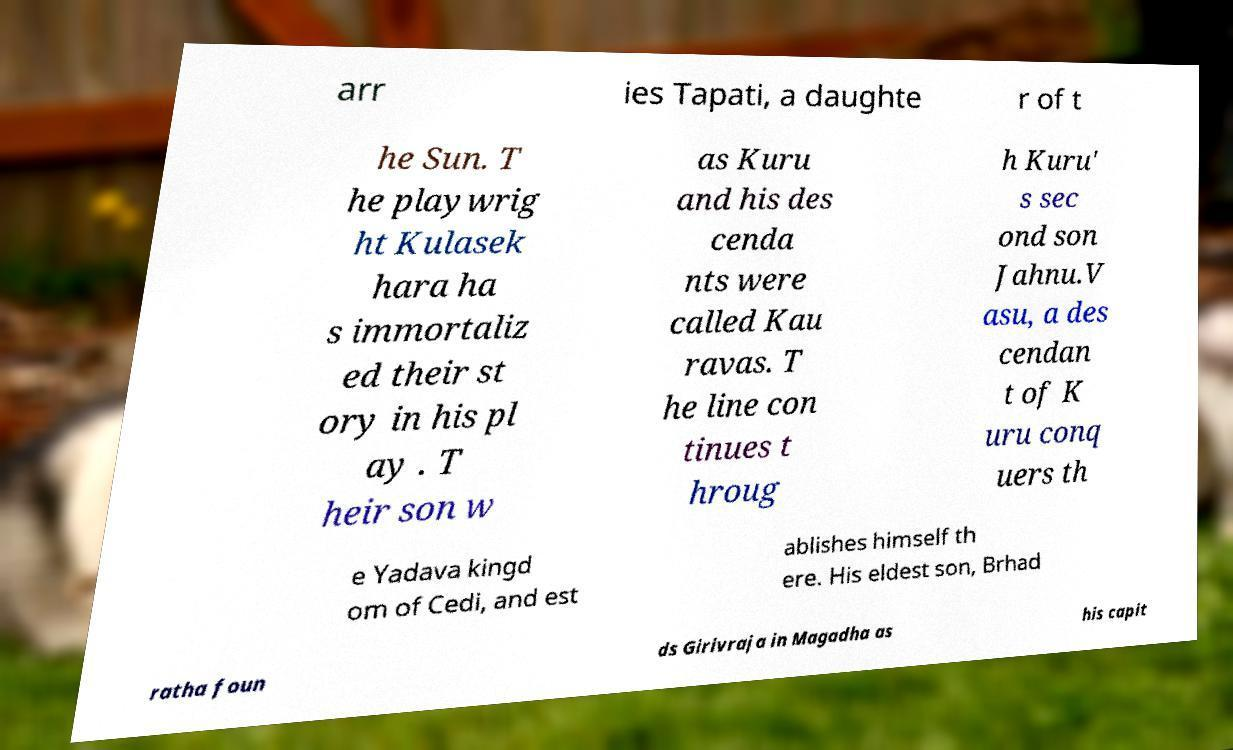I need the written content from this picture converted into text. Can you do that? arr ies Tapati, a daughte r of t he Sun. T he playwrig ht Kulasek hara ha s immortaliz ed their st ory in his pl ay . T heir son w as Kuru and his des cenda nts were called Kau ravas. T he line con tinues t hroug h Kuru' s sec ond son Jahnu.V asu, a des cendan t of K uru conq uers th e Yadava kingd om of Cedi, and est ablishes himself th ere. His eldest son, Brhad ratha foun ds Girivraja in Magadha as his capit 